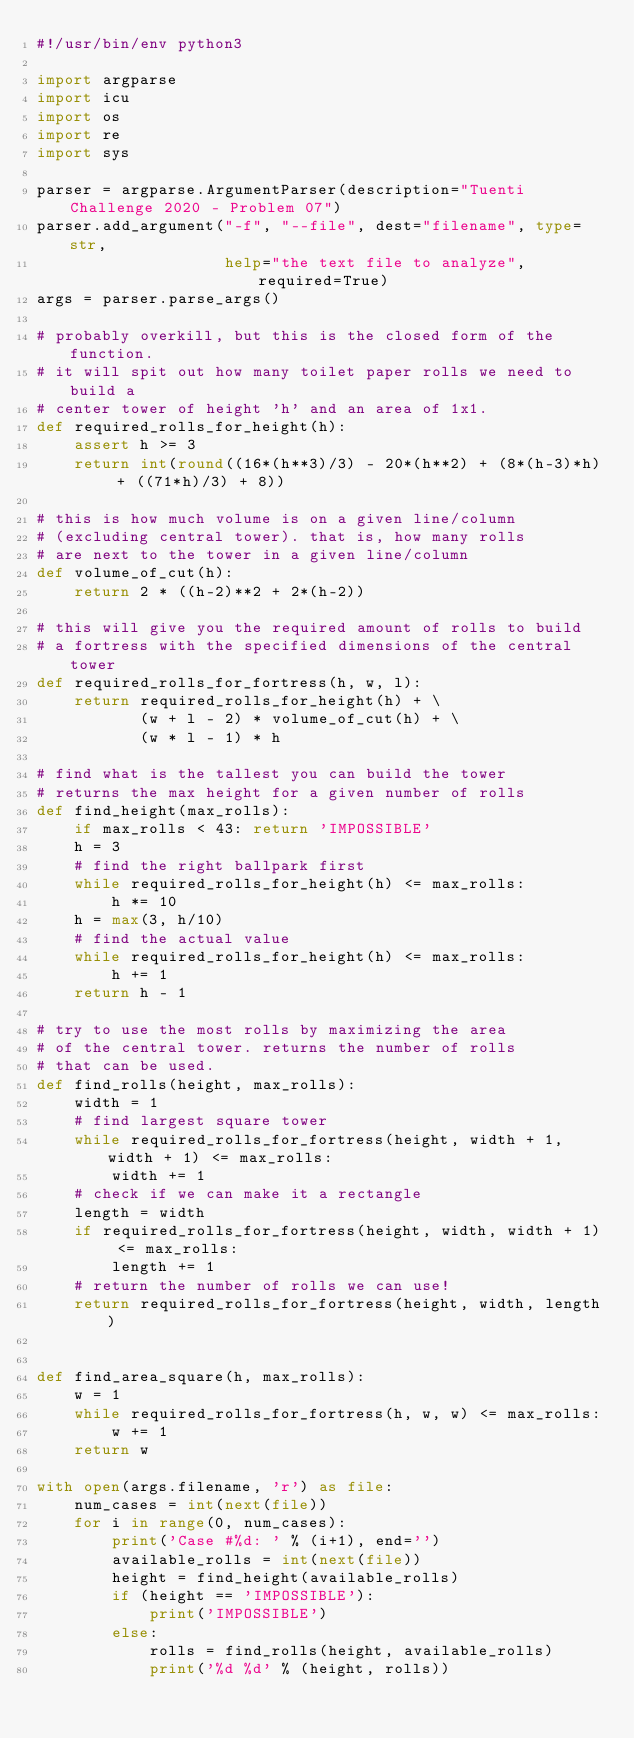Convert code to text. <code><loc_0><loc_0><loc_500><loc_500><_Python_>#!/usr/bin/env python3

import argparse
import icu
import os
import re
import sys

parser = argparse.ArgumentParser(description="Tuenti Challenge 2020 - Problem 07")
parser.add_argument("-f", "--file", dest="filename", type=str,
                    help="the text file to analyze", required=True)
args = parser.parse_args()

# probably overkill, but this is the closed form of the function.
# it will spit out how many toilet paper rolls we need to build a
# center tower of height 'h' and an area of 1x1.
def required_rolls_for_height(h):
    assert h >= 3
    return int(round((16*(h**3)/3) - 20*(h**2) + (8*(h-3)*h) + ((71*h)/3) + 8))

# this is how much volume is on a given line/column
# (excluding central tower). that is, how many rolls
# are next to the tower in a given line/column
def volume_of_cut(h):
    return 2 * ((h-2)**2 + 2*(h-2))

# this will give you the required amount of rolls to build
# a fortress with the specified dimensions of the central tower
def required_rolls_for_fortress(h, w, l):
    return required_rolls_for_height(h) + \
           (w + l - 2) * volume_of_cut(h) + \
           (w * l - 1) * h

# find what is the tallest you can build the tower
# returns the max height for a given number of rolls
def find_height(max_rolls):
    if max_rolls < 43: return 'IMPOSSIBLE'
    h = 3
    # find the right ballpark first
    while required_rolls_for_height(h) <= max_rolls:
        h *= 10
    h = max(3, h/10)
    # find the actual value
    while required_rolls_for_height(h) <= max_rolls:
        h += 1
    return h - 1

# try to use the most rolls by maximizing the area
# of the central tower. returns the number of rolls
# that can be used.
def find_rolls(height, max_rolls):
    width = 1
    # find largest square tower
    while required_rolls_for_fortress(height, width + 1, width + 1) <= max_rolls:
        width += 1
    # check if we can make it a rectangle
    length = width
    if required_rolls_for_fortress(height, width, width + 1) <= max_rolls:
        length += 1
    # return the number of rolls we can use!
    return required_rolls_for_fortress(height, width, length)


def find_area_square(h, max_rolls):
    w = 1
    while required_rolls_for_fortress(h, w, w) <= max_rolls:
        w += 1
    return w

with open(args.filename, 'r') as file:
    num_cases = int(next(file))
    for i in range(0, num_cases):
        print('Case #%d: ' % (i+1), end='')
        available_rolls = int(next(file))
        height = find_height(available_rolls)
        if (height == 'IMPOSSIBLE'):
            print('IMPOSSIBLE')
        else:
            rolls = find_rolls(height, available_rolls)
            print('%d %d' % (height, rolls))
</code> 